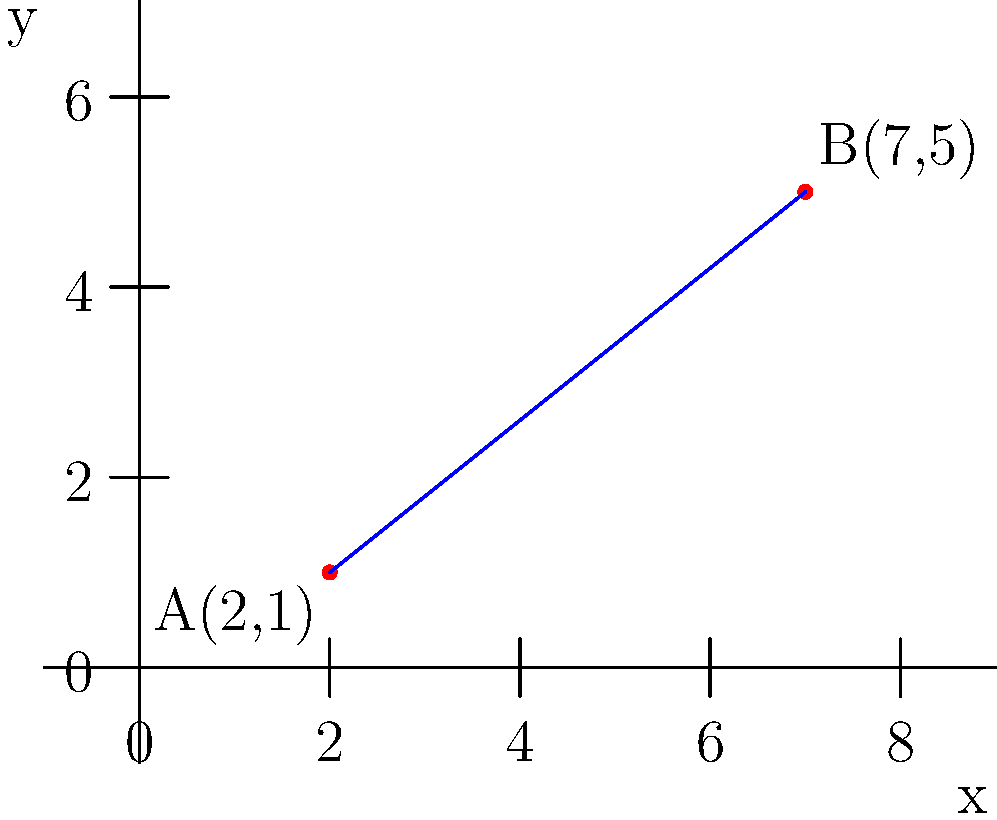In a study on the correlation between dietary fiber intake and insulin sensitivity, two data points are plotted on a coordinate plane. Point A represents a patient with low fiber intake and low insulin sensitivity, while point B represents a patient with high fiber intake and high insulin sensitivity. If point A is located at (2,1) and point B is at (7,5), calculate the distance between these two points to quantify the potential impact of dietary fiber on insulin sensitivity. To find the distance between two points on a coordinate plane, we can use the distance formula, which is derived from the Pythagorean theorem:

Distance = $\sqrt{(x_2-x_1)^2 + (y_2-y_1)^2}$

Where $(x_1,y_1)$ are the coordinates of the first point and $(x_2,y_2)$ are the coordinates of the second point.

Given:
Point A: $(x_1,y_1) = (2,1)$
Point B: $(x_2,y_2) = (7,5)$

Let's substitute these values into the formula:

Distance = $\sqrt{(7-2)^2 + (5-1)^2}$

Now, let's solve step by step:

1) First, calculate the differences:
   $7-2 = 5$
   $5-1 = 4$

2) Square these differences:
   $5^2 = 25$
   $4^2 = 16$

3) Add the squared differences:
   $25 + 16 = 41$

4) Take the square root of the sum:
   $\sqrt{41}$

5) Simplify:
   The square root of 41 cannot be simplified further, so this is our final answer.

Therefore, the distance between points A and B is $\sqrt{41}$ units.
Answer: $\sqrt{41}$ units 